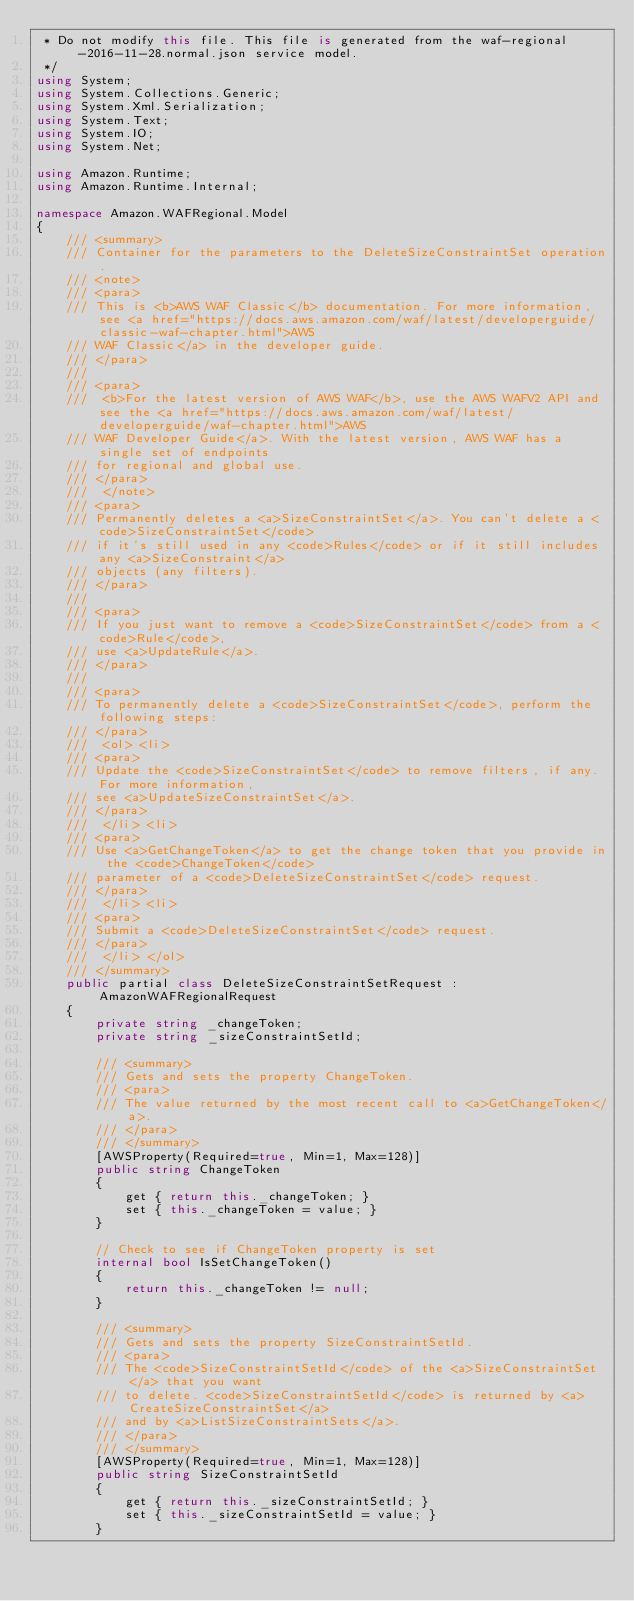Convert code to text. <code><loc_0><loc_0><loc_500><loc_500><_C#_> * Do not modify this file. This file is generated from the waf-regional-2016-11-28.normal.json service model.
 */
using System;
using System.Collections.Generic;
using System.Xml.Serialization;
using System.Text;
using System.IO;
using System.Net;

using Amazon.Runtime;
using Amazon.Runtime.Internal;

namespace Amazon.WAFRegional.Model
{
    /// <summary>
    /// Container for the parameters to the DeleteSizeConstraintSet operation.
    /// <note> 
    /// <para>
    /// This is <b>AWS WAF Classic</b> documentation. For more information, see <a href="https://docs.aws.amazon.com/waf/latest/developerguide/classic-waf-chapter.html">AWS
    /// WAF Classic</a> in the developer guide.
    /// </para>
    ///  
    /// <para>
    ///  <b>For the latest version of AWS WAF</b>, use the AWS WAFV2 API and see the <a href="https://docs.aws.amazon.com/waf/latest/developerguide/waf-chapter.html">AWS
    /// WAF Developer Guide</a>. With the latest version, AWS WAF has a single set of endpoints
    /// for regional and global use. 
    /// </para>
    ///  </note> 
    /// <para>
    /// Permanently deletes a <a>SizeConstraintSet</a>. You can't delete a <code>SizeConstraintSet</code>
    /// if it's still used in any <code>Rules</code> or if it still includes any <a>SizeConstraint</a>
    /// objects (any filters).
    /// </para>
    ///  
    /// <para>
    /// If you just want to remove a <code>SizeConstraintSet</code> from a <code>Rule</code>,
    /// use <a>UpdateRule</a>.
    /// </para>
    ///  
    /// <para>
    /// To permanently delete a <code>SizeConstraintSet</code>, perform the following steps:
    /// </para>
    ///  <ol> <li> 
    /// <para>
    /// Update the <code>SizeConstraintSet</code> to remove filters, if any. For more information,
    /// see <a>UpdateSizeConstraintSet</a>.
    /// </para>
    ///  </li> <li> 
    /// <para>
    /// Use <a>GetChangeToken</a> to get the change token that you provide in the <code>ChangeToken</code>
    /// parameter of a <code>DeleteSizeConstraintSet</code> request.
    /// </para>
    ///  </li> <li> 
    /// <para>
    /// Submit a <code>DeleteSizeConstraintSet</code> request.
    /// </para>
    ///  </li> </ol>
    /// </summary>
    public partial class DeleteSizeConstraintSetRequest : AmazonWAFRegionalRequest
    {
        private string _changeToken;
        private string _sizeConstraintSetId;

        /// <summary>
        /// Gets and sets the property ChangeToken. 
        /// <para>
        /// The value returned by the most recent call to <a>GetChangeToken</a>.
        /// </para>
        /// </summary>
        [AWSProperty(Required=true, Min=1, Max=128)]
        public string ChangeToken
        {
            get { return this._changeToken; }
            set { this._changeToken = value; }
        }

        // Check to see if ChangeToken property is set
        internal bool IsSetChangeToken()
        {
            return this._changeToken != null;
        }

        /// <summary>
        /// Gets and sets the property SizeConstraintSetId. 
        /// <para>
        /// The <code>SizeConstraintSetId</code> of the <a>SizeConstraintSet</a> that you want
        /// to delete. <code>SizeConstraintSetId</code> is returned by <a>CreateSizeConstraintSet</a>
        /// and by <a>ListSizeConstraintSets</a>.
        /// </para>
        /// </summary>
        [AWSProperty(Required=true, Min=1, Max=128)]
        public string SizeConstraintSetId
        {
            get { return this._sizeConstraintSetId; }
            set { this._sizeConstraintSetId = value; }
        }
</code> 